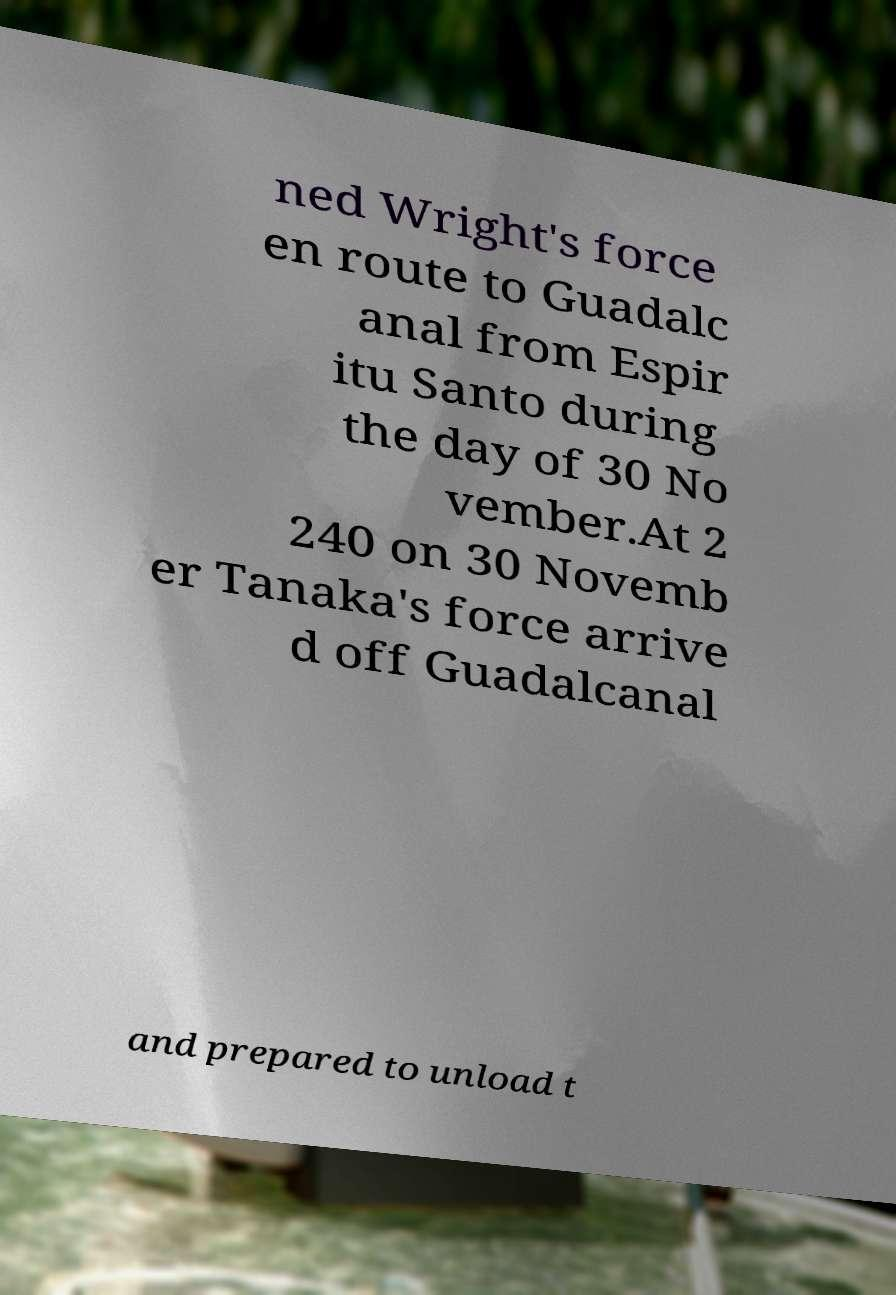I need the written content from this picture converted into text. Can you do that? ned Wright's force en route to Guadalc anal from Espir itu Santo during the day of 30 No vember.At 2 240 on 30 Novemb er Tanaka's force arrive d off Guadalcanal and prepared to unload t 